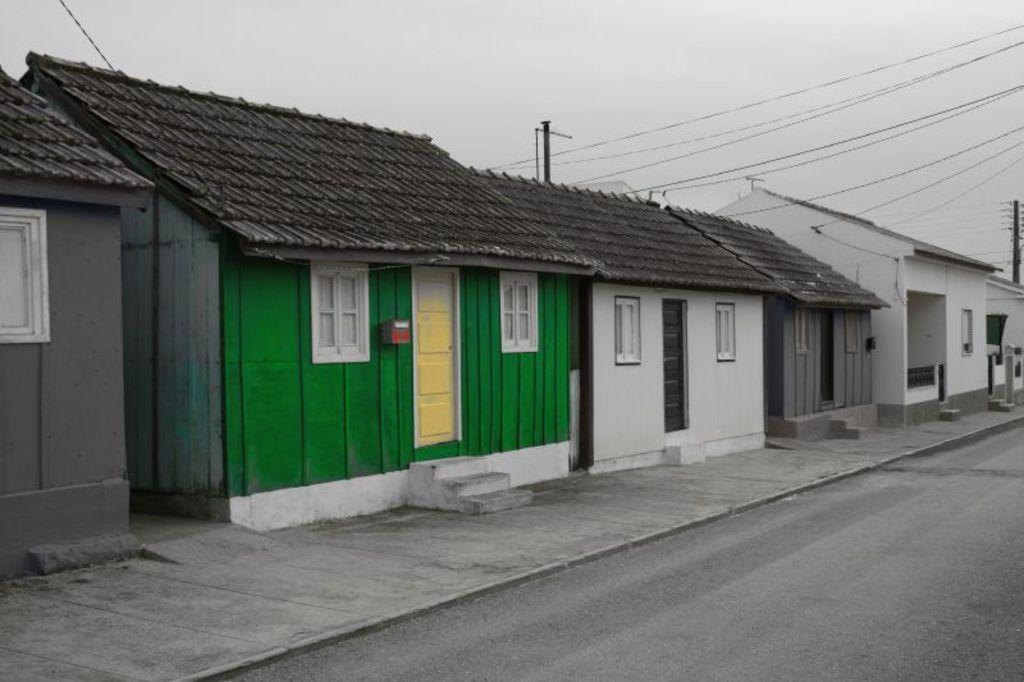What is the color scheme of the image? The image is in black and white. What stands out in terms of color in the image? There is a green color home in the middle of the image. How are the other homes depicted in the image? The remaining homes are in black and white color. What can be seen in the background of the image? The sky is visible in the image. How many clover leaves can be seen growing near the green home in the image? There is no clover present in the image, so it is not possible to determine the number of leaves. What type of feet can be seen walking on the roof of the green home in the image? There are no feet or people visible on the roof of the green home in the image. 